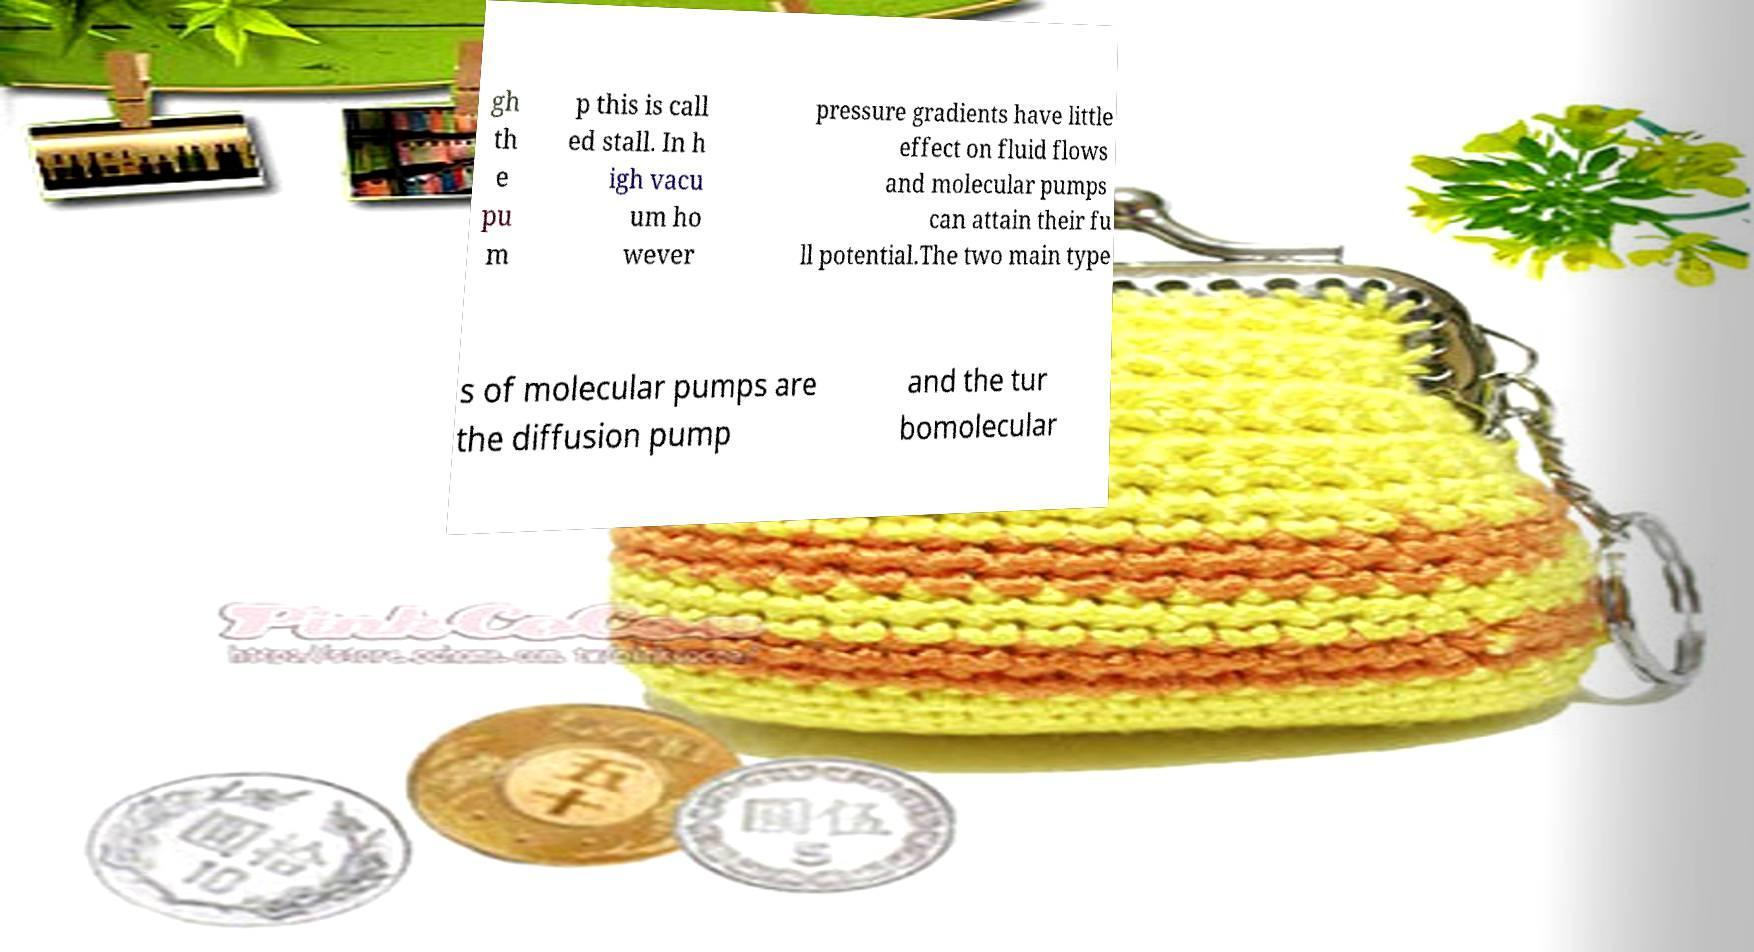Please read and relay the text visible in this image. What does it say? gh th e pu m p this is call ed stall. In h igh vacu um ho wever pressure gradients have little effect on fluid flows and molecular pumps can attain their fu ll potential.The two main type s of molecular pumps are the diffusion pump and the tur bomolecular 